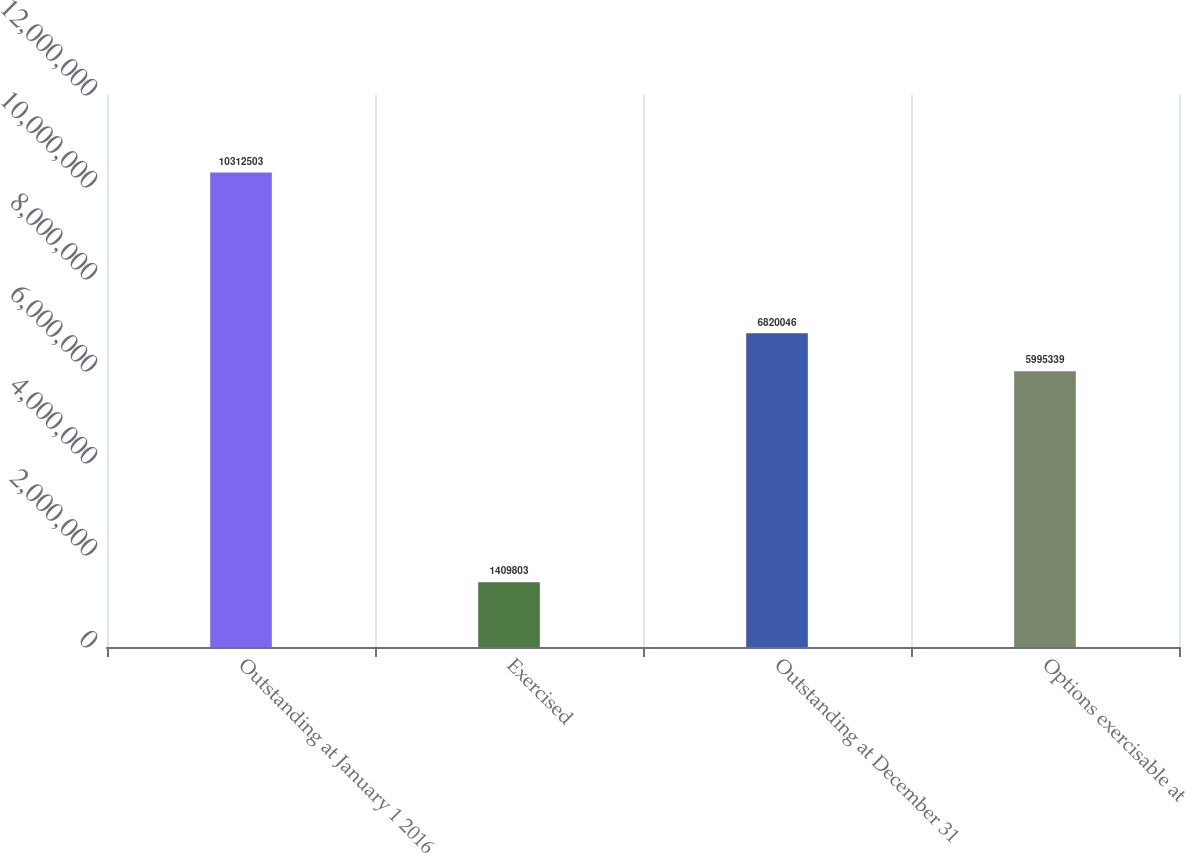<chart> <loc_0><loc_0><loc_500><loc_500><bar_chart><fcel>Outstanding at January 1 2016<fcel>Exercised<fcel>Outstanding at December 31<fcel>Options exercisable at<nl><fcel>1.03125e+07<fcel>1.4098e+06<fcel>6.82005e+06<fcel>5.99534e+06<nl></chart> 